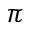Convert formula to latex. <formula><loc_0><loc_0><loc_500><loc_500>\pi</formula> 